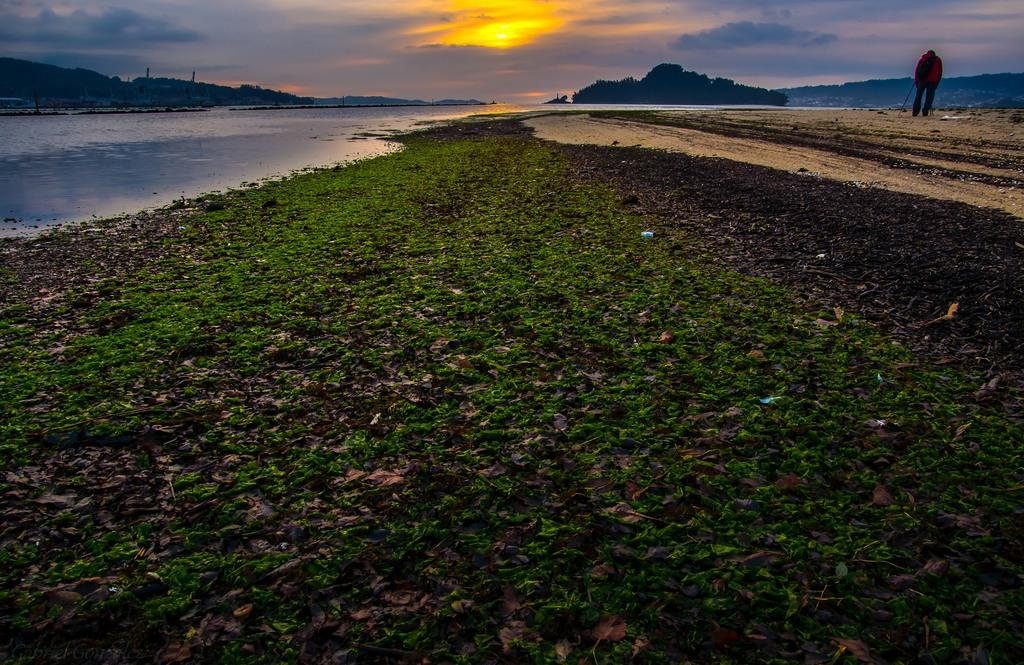What type of natural environment is depicted in the image? The image contains grass and water, which suggests a natural environment. What can be seen in the sky in the image? There are clouds visible in the sky in the image. What is the overall setting of the image? The sky is visible in the image, indicating an outdoor setting. Can you describe the person in the image? There is a person standing in the image. What type of hole can be seen in the person's back in the image? There is no hole or wound visible on the person's back in the image. 